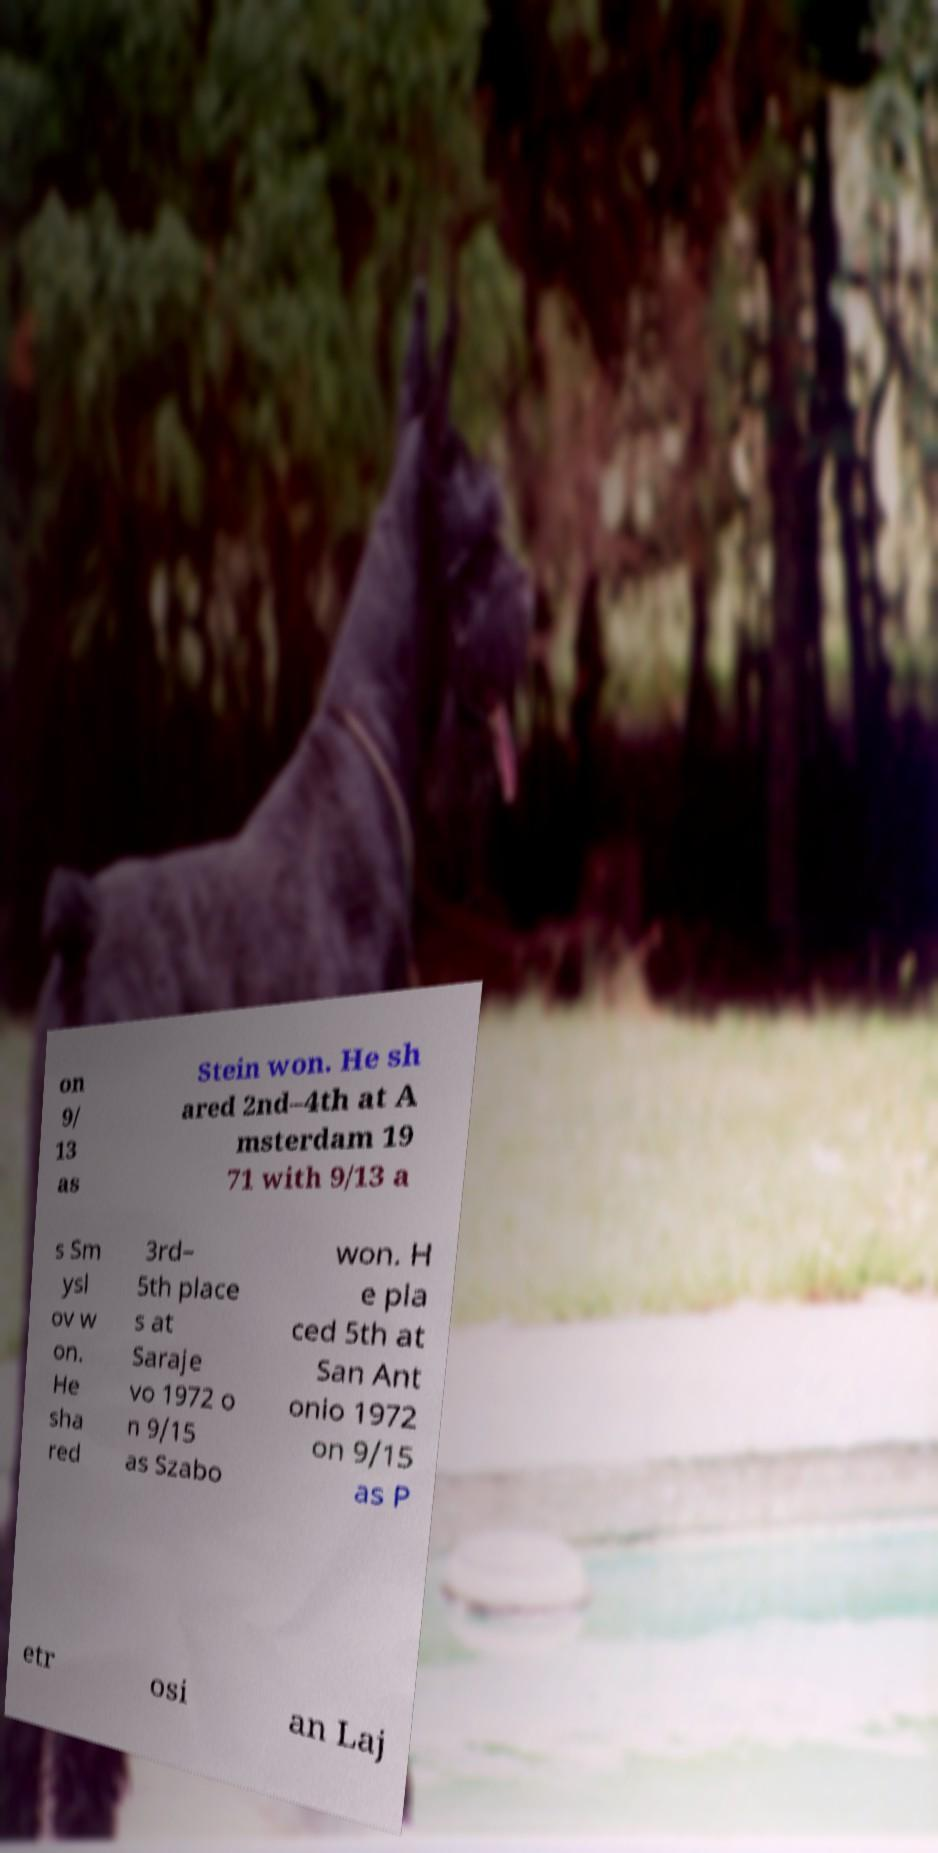Can you accurately transcribe the text from the provided image for me? on 9/ 13 as Stein won. He sh ared 2nd–4th at A msterdam 19 71 with 9/13 a s Sm ysl ov w on. He sha red 3rd– 5th place s at Saraje vo 1972 o n 9/15 as Szabo won. H e pla ced 5th at San Ant onio 1972 on 9/15 as P etr osi an Laj 